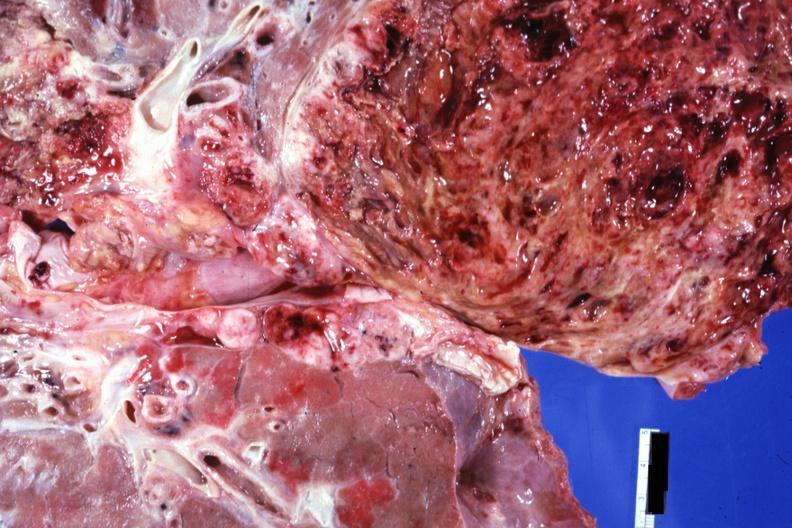s iron cut surface?
Answer the question using a single word or phrase. No 